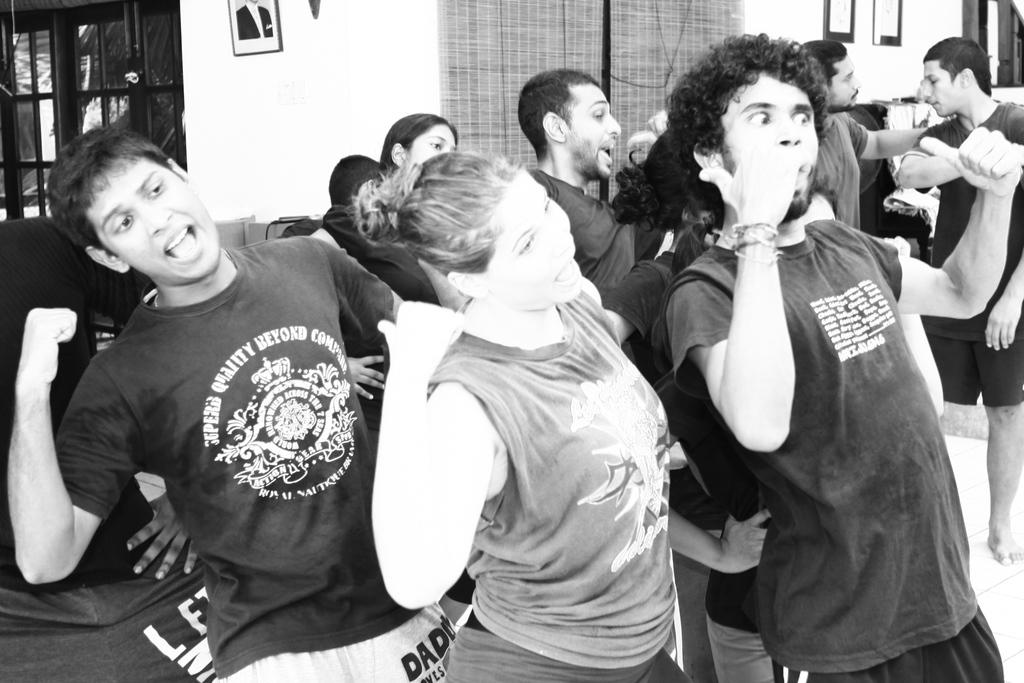What is the color scheme of the image? The image is black and white. What can be seen in the foreground of the image? There are people standing in the image. What is visible in the background of the image? There are windows and photo frames on the wall in the background of the image. How does the wind affect the people in the image? There is no wind present in the image; it is a still, black and white photograph. What type of toothbrush is hanging on the wall in the image? There are no toothbrushes present in the image; it features people standing and windows with photo frames on the wall. 